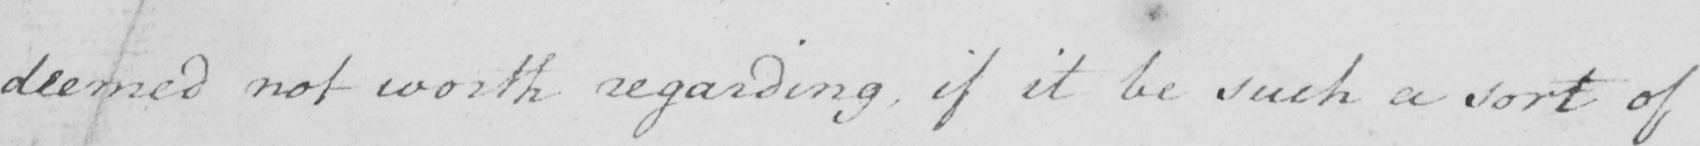Transcribe the text shown in this historical manuscript line. deemed not worth regarding , if it be such a sort of 